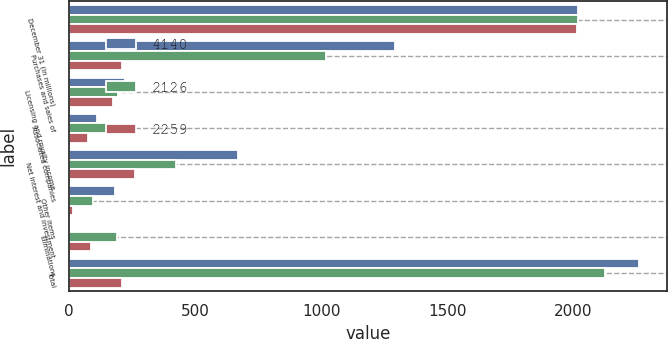Convert chart to OTSL. <chart><loc_0><loc_0><loc_500><loc_500><stacked_bar_chart><ecel><fcel>December 31 (In millions)<fcel>Purchases and sales of<fcel>Licensing and royalty income<fcel>Associated companies<fcel>Net interest and investment<fcel>Other items<fcel>Eliminations<fcel>Total<nl><fcel>4140<fcel>2018<fcel>1294<fcel>221<fcel>111<fcel>669<fcel>182<fcel>4<fcel>2259<nl><fcel>2126<fcel>2017<fcel>1021<fcel>193<fcel>202<fcel>425<fcel>96<fcel>189<fcel>2126<nl><fcel>2259<fcel>2016<fcel>211.5<fcel>175<fcel>76<fcel>263<fcel>17<fcel>87<fcel>211.5<nl></chart> 